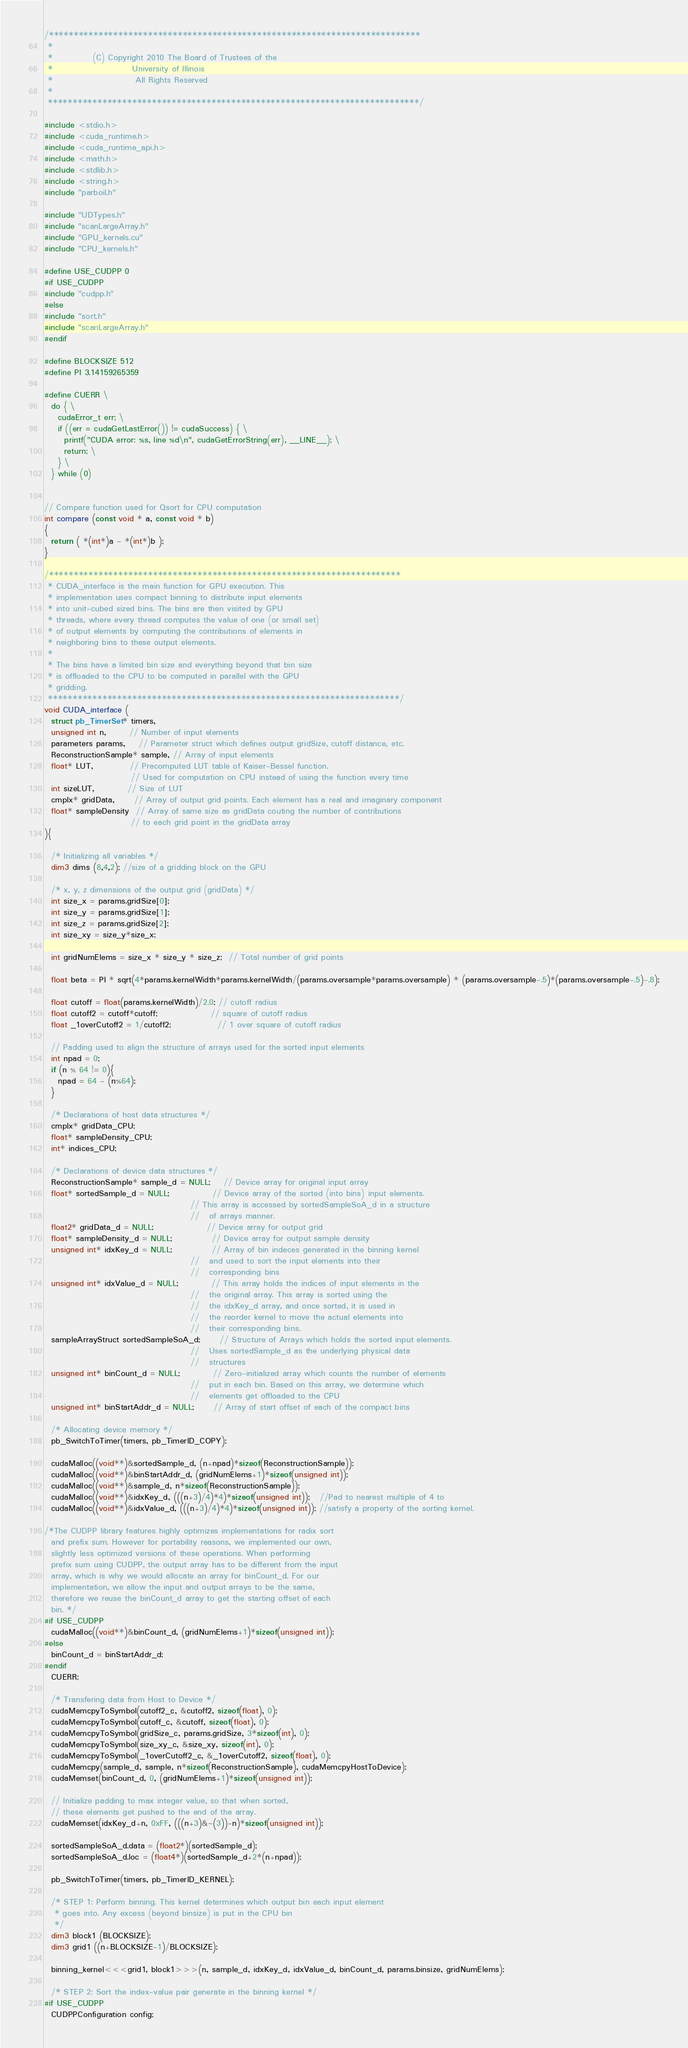Convert code to text. <code><loc_0><loc_0><loc_500><loc_500><_Cuda_>/***************************************************************************
 *
 *            (C) Copyright 2010 The Board of Trustees of the
 *                        University of Illinois
 *                         All Rights Reserved
 *
 ***************************************************************************/

#include <stdio.h>
#include <cuda_runtime.h>
#include <cuda_runtime_api.h>
#include <math.h>
#include <stdlib.h>
#include <string.h>
#include "parboil.h"

#include "UDTypes.h"
#include "scanLargeArray.h"
#include "GPU_kernels.cu"
#include "CPU_kernels.h"

#define USE_CUDPP 0
#if USE_CUDPP
#include "cudpp.h"
#else
#include "sort.h"
#include "scanLargeArray.h"
#endif

#define BLOCKSIZE 512
#define PI 3.14159265359

#define CUERR \
  do { \
    cudaError_t err; \
    if ((err = cudaGetLastError()) != cudaSuccess) { \
      printf("CUDA error: %s, line %d\n", cudaGetErrorString(err), __LINE__); \
      return; \
    } \
  } while (0)


// Compare function used for Qsort for CPU computation
int compare (const void * a, const void * b)
{
  return ( *(int*)a - *(int*)b );
}

/***********************************************************************
 * CUDA_interface is the main function for GPU execution. This
 * implementation uses compact binning to distribute input elements
 * into unit-cubed sized bins. The bins are then visited by GPU
 * threads, where every thread computes the value of one (or small set)
 * of output elements by computing the contributions of elements in 
 * neighboring bins to these output elements.
 *
 * The bins have a limited bin size and everything beyond that bin size
 * is offloaded to the CPU to be computed in parallel with the GPU
 * gridding.
 ***********************************************************************/
void CUDA_interface (
  struct pb_TimerSet* timers,
  unsigned int n,       // Number of input elements
  parameters params,    // Parameter struct which defines output gridSize, cutoff distance, etc.
  ReconstructionSample* sample, // Array of input elements
  float* LUT,           // Precomputed LUT table of Kaiser-Bessel function. 
                          // Used for computation on CPU instead of using the function every time
  int sizeLUT,          // Size of LUT
  cmplx* gridData,      // Array of output grid points. Each element has a real and imaginary component
  float* sampleDensity  // Array of same size as gridData couting the number of contributions
                          // to each grid point in the gridData array
){

  /* Initializing all variables */
  dim3 dims (8,4,2); //size of a gridding block on the GPU

  /* x, y, z dimensions of the output grid (gridData) */
  int size_x = params.gridSize[0];
  int size_y = params.gridSize[1];
  int size_z = params.gridSize[2];
  int size_xy = size_y*size_x;

  int gridNumElems = size_x * size_y * size_z;  // Total number of grid points

  float beta = PI * sqrt(4*params.kernelWidth*params.kernelWidth/(params.oversample*params.oversample) * (params.oversample-.5)*(params.oversample-.5)-.8);

  float cutoff = float(params.kernelWidth)/2.0; // cutoff radius
  float cutoff2 = cutoff*cutoff;                // square of cutoff radius
  float _1overCutoff2 = 1/cutoff2;              // 1 over square of cutoff radius

  // Padding used to align the structure of arrays used for the sorted input elements
  int npad = 0;
  if (n % 64 != 0){
    npad = 64 - (n%64);
  }

  /* Declarations of host data structures */
  cmplx* gridData_CPU;
  float* sampleDensity_CPU;
  int* indices_CPU;

  /* Declarations of device data structures */
  ReconstructionSample* sample_d = NULL;    // Device array for original input array
  float* sortedSample_d = NULL;             // Device array of the sorted (into bins) input elements.
                                            // This array is accessed by sortedSampleSoA_d in a structure
                                            //   of arrays manner.
  float2* gridData_d = NULL;                // Device array for output grid
  float* sampleDensity_d = NULL;            // Device array for output sample density
  unsigned int* idxKey_d = NULL;            // Array of bin indeces generated in the binning kernel
                                            //   and used to sort the input elements into their
                                            //   corresponding bins
  unsigned int* idxValue_d = NULL;          // This array holds the indices of input elements in the
                                            //   the original array. This array is sorted using the
                                            //   the idxKey_d array, and once sorted, it is used in
                                            //   the reorder kernel to move the actual elements into
                                            //   their corresponding bins.
  sampleArrayStruct sortedSampleSoA_d;      // Structure of Arrays which holds the sorted input elements.
                                            //   Uses sortedSample_d as the underlying physical data
                                            //   structures
  unsigned int* binCount_d = NULL;          // Zero-initialized array which counts the number of elements
                                            //   put in each bin. Based on this array, we determine which
                                            //   elements get offloaded to the CPU
  unsigned int* binStartAddr_d = NULL;      // Array of start offset of each of the compact bins

  /* Allocating device memory */
  pb_SwitchToTimer(timers, pb_TimerID_COPY);

  cudaMalloc((void**)&sortedSample_d, (n+npad)*sizeof(ReconstructionSample));
  cudaMalloc((void**)&binStartAddr_d, (gridNumElems+1)*sizeof(unsigned int));
  cudaMalloc((void**)&sample_d, n*sizeof(ReconstructionSample));
  cudaMalloc((void**)&idxKey_d, (((n+3)/4)*4)*sizeof(unsigned int));   //Pad to nearest multiple of 4 to 
  cudaMalloc((void**)&idxValue_d, (((n+3)/4)*4)*sizeof(unsigned int)); //satisfy a property of the sorting kernel.

/*The CUDPP library features highly optimizes implementations for radix sort
  and prefix sum. However for portability reasons, we implemented our own,
  slightly less optimized versions of these operations. When performing
  prefix sum using CUDPP, the output array has to be different from the input
  array, which is why we would allocate an array for binCount_d. For our
  implementation, we allow the input and output arrays to be the same,
  therefore we reuse the binCount_d array to get the starting offset of each
  bin. */
#if USE_CUDPP
  cudaMalloc((void**)&binCount_d, (gridNumElems+1)*sizeof(unsigned int));
#else
  binCount_d = binStartAddr_d;
#endif
  CUERR;

  /* Transfering data from Host to Device */
  cudaMemcpyToSymbol(cutoff2_c, &cutoff2, sizeof(float), 0);
  cudaMemcpyToSymbol(cutoff_c, &cutoff, sizeof(float), 0);
  cudaMemcpyToSymbol(gridSize_c, params.gridSize, 3*sizeof(int), 0);
  cudaMemcpyToSymbol(size_xy_c, &size_xy, sizeof(int), 0);
  cudaMemcpyToSymbol(_1overCutoff2_c, &_1overCutoff2, sizeof(float), 0);
  cudaMemcpy(sample_d, sample, n*sizeof(ReconstructionSample), cudaMemcpyHostToDevice);
  cudaMemset(binCount_d, 0, (gridNumElems+1)*sizeof(unsigned int));

  // Initialize padding to max integer value, so that when sorted,
  // these elements get pushed to the end of the array.
  cudaMemset(idxKey_d+n, 0xFF, (((n+3)&~(3))-n)*sizeof(unsigned int));

  sortedSampleSoA_d.data = (float2*)(sortedSample_d);
  sortedSampleSoA_d.loc = (float4*)(sortedSample_d+2*(n+npad));

  pb_SwitchToTimer(timers, pb_TimerID_KERNEL);

  /* STEP 1: Perform binning. This kernel determines which output bin each input element
   * goes into. Any excess (beyond binsize) is put in the CPU bin
   */
  dim3 block1 (BLOCKSIZE);
  dim3 grid1 ((n+BLOCKSIZE-1)/BLOCKSIZE);

  binning_kernel<<<grid1, block1>>>(n, sample_d, idxKey_d, idxValue_d, binCount_d, params.binsize, gridNumElems);

  /* STEP 2: Sort the index-value pair generate in the binning kernel */
#if USE_CUDPP
  CUDPPConfiguration config;</code> 